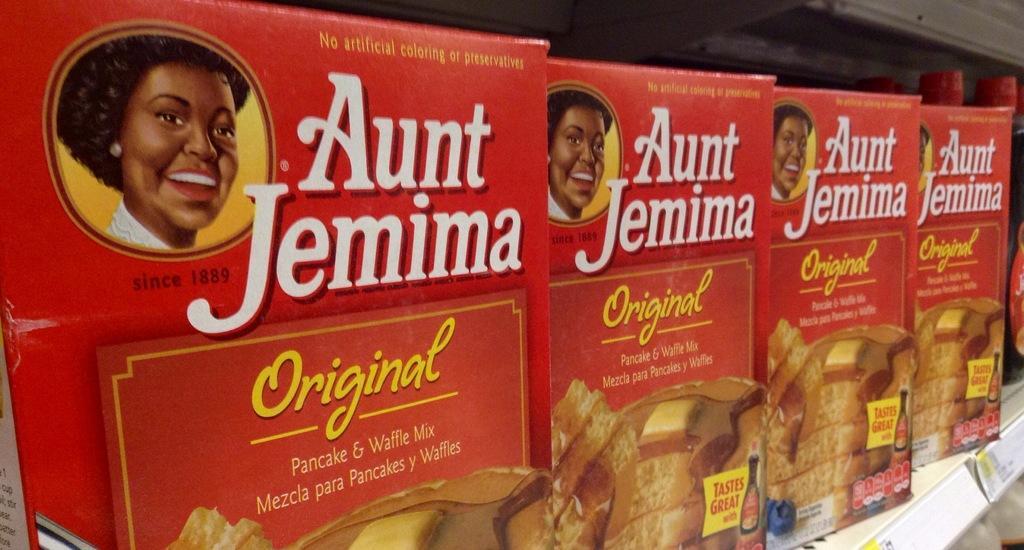Describe this image in one or two sentences. In this image I can see a rack which is cream in color and few white and yellow colored boards attached to the racks. I can see few boxes which are red, yellow, white and brown in color are in the racks. I can see a woman's face is printed on the boxes. In the background I can see few bottles with red colored stickers and red colored caps. 